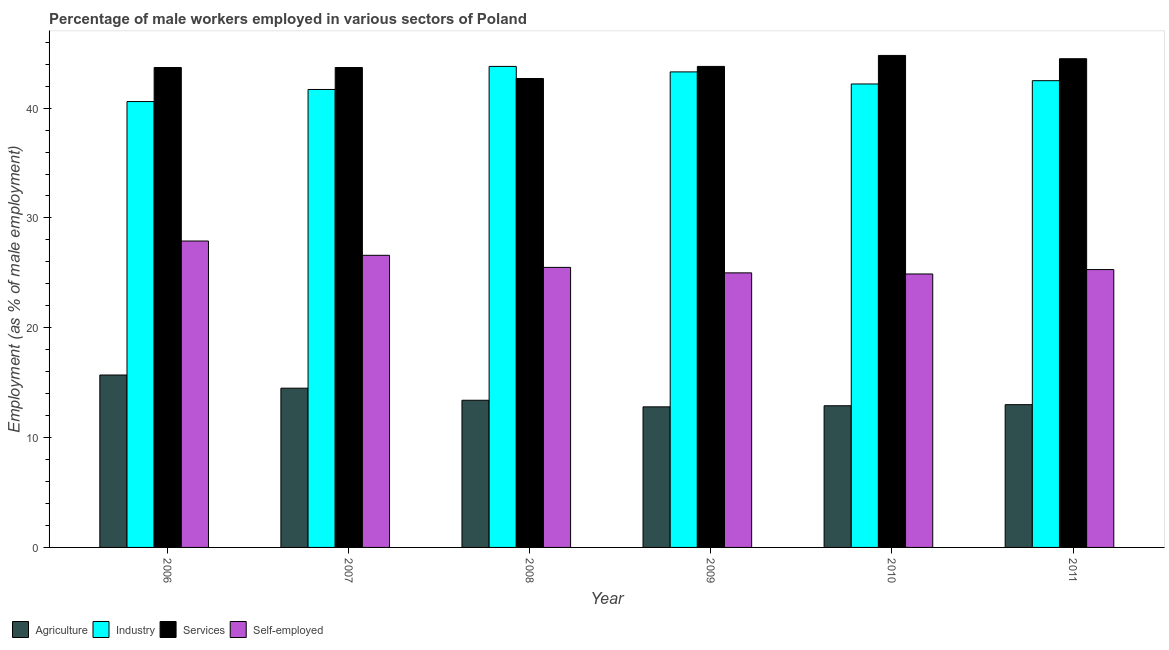How many different coloured bars are there?
Provide a succinct answer. 4. How many bars are there on the 3rd tick from the left?
Offer a terse response. 4. How many bars are there on the 6th tick from the right?
Make the answer very short. 4. What is the percentage of self employed male workers in 2006?
Your response must be concise. 27.9. Across all years, what is the maximum percentage of self employed male workers?
Provide a succinct answer. 27.9. Across all years, what is the minimum percentage of male workers in agriculture?
Your response must be concise. 12.8. What is the total percentage of male workers in agriculture in the graph?
Ensure brevity in your answer.  82.3. What is the difference between the percentage of male workers in agriculture in 2007 and that in 2010?
Keep it short and to the point. 1.6. What is the difference between the percentage of male workers in agriculture in 2010 and the percentage of male workers in services in 2007?
Provide a short and direct response. -1.6. What is the average percentage of male workers in services per year?
Provide a short and direct response. 43.87. In the year 2009, what is the difference between the percentage of male workers in agriculture and percentage of male workers in industry?
Provide a succinct answer. 0. What is the ratio of the percentage of male workers in agriculture in 2006 to that in 2011?
Your answer should be compact. 1.21. What is the difference between the highest and the second highest percentage of self employed male workers?
Your answer should be very brief. 1.3. What is the difference between the highest and the lowest percentage of self employed male workers?
Ensure brevity in your answer.  3. Is the sum of the percentage of male workers in industry in 2006 and 2011 greater than the maximum percentage of male workers in agriculture across all years?
Your response must be concise. Yes. What does the 3rd bar from the left in 2009 represents?
Provide a short and direct response. Services. What does the 4th bar from the right in 2007 represents?
Ensure brevity in your answer.  Agriculture. Are the values on the major ticks of Y-axis written in scientific E-notation?
Ensure brevity in your answer.  No. Does the graph contain any zero values?
Ensure brevity in your answer.  No. Does the graph contain grids?
Make the answer very short. No. How are the legend labels stacked?
Keep it short and to the point. Horizontal. What is the title of the graph?
Provide a short and direct response. Percentage of male workers employed in various sectors of Poland. What is the label or title of the Y-axis?
Offer a terse response. Employment (as % of male employment). What is the Employment (as % of male employment) in Agriculture in 2006?
Ensure brevity in your answer.  15.7. What is the Employment (as % of male employment) of Industry in 2006?
Your answer should be very brief. 40.6. What is the Employment (as % of male employment) in Services in 2006?
Provide a short and direct response. 43.7. What is the Employment (as % of male employment) in Self-employed in 2006?
Provide a short and direct response. 27.9. What is the Employment (as % of male employment) in Industry in 2007?
Offer a terse response. 41.7. What is the Employment (as % of male employment) of Services in 2007?
Provide a succinct answer. 43.7. What is the Employment (as % of male employment) of Self-employed in 2007?
Provide a succinct answer. 26.6. What is the Employment (as % of male employment) of Agriculture in 2008?
Provide a short and direct response. 13.4. What is the Employment (as % of male employment) of Industry in 2008?
Provide a short and direct response. 43.8. What is the Employment (as % of male employment) in Services in 2008?
Make the answer very short. 42.7. What is the Employment (as % of male employment) in Self-employed in 2008?
Make the answer very short. 25.5. What is the Employment (as % of male employment) in Agriculture in 2009?
Offer a very short reply. 12.8. What is the Employment (as % of male employment) of Industry in 2009?
Your answer should be very brief. 43.3. What is the Employment (as % of male employment) in Services in 2009?
Your response must be concise. 43.8. What is the Employment (as % of male employment) of Self-employed in 2009?
Your answer should be very brief. 25. What is the Employment (as % of male employment) in Agriculture in 2010?
Ensure brevity in your answer.  12.9. What is the Employment (as % of male employment) of Industry in 2010?
Ensure brevity in your answer.  42.2. What is the Employment (as % of male employment) of Services in 2010?
Provide a short and direct response. 44.8. What is the Employment (as % of male employment) of Self-employed in 2010?
Keep it short and to the point. 24.9. What is the Employment (as % of male employment) of Agriculture in 2011?
Give a very brief answer. 13. What is the Employment (as % of male employment) of Industry in 2011?
Give a very brief answer. 42.5. What is the Employment (as % of male employment) in Services in 2011?
Provide a succinct answer. 44.5. What is the Employment (as % of male employment) of Self-employed in 2011?
Ensure brevity in your answer.  25.3. Across all years, what is the maximum Employment (as % of male employment) in Agriculture?
Offer a very short reply. 15.7. Across all years, what is the maximum Employment (as % of male employment) of Industry?
Provide a succinct answer. 43.8. Across all years, what is the maximum Employment (as % of male employment) in Services?
Keep it short and to the point. 44.8. Across all years, what is the maximum Employment (as % of male employment) in Self-employed?
Offer a very short reply. 27.9. Across all years, what is the minimum Employment (as % of male employment) of Agriculture?
Give a very brief answer. 12.8. Across all years, what is the minimum Employment (as % of male employment) in Industry?
Your response must be concise. 40.6. Across all years, what is the minimum Employment (as % of male employment) in Services?
Make the answer very short. 42.7. Across all years, what is the minimum Employment (as % of male employment) of Self-employed?
Provide a succinct answer. 24.9. What is the total Employment (as % of male employment) of Agriculture in the graph?
Give a very brief answer. 82.3. What is the total Employment (as % of male employment) of Industry in the graph?
Ensure brevity in your answer.  254.1. What is the total Employment (as % of male employment) of Services in the graph?
Your answer should be very brief. 263.2. What is the total Employment (as % of male employment) of Self-employed in the graph?
Offer a very short reply. 155.2. What is the difference between the Employment (as % of male employment) of Industry in 2006 and that in 2007?
Offer a very short reply. -1.1. What is the difference between the Employment (as % of male employment) in Self-employed in 2006 and that in 2007?
Ensure brevity in your answer.  1.3. What is the difference between the Employment (as % of male employment) in Agriculture in 2006 and that in 2008?
Your answer should be very brief. 2.3. What is the difference between the Employment (as % of male employment) in Industry in 2006 and that in 2008?
Provide a short and direct response. -3.2. What is the difference between the Employment (as % of male employment) of Services in 2006 and that in 2008?
Provide a short and direct response. 1. What is the difference between the Employment (as % of male employment) of Self-employed in 2006 and that in 2008?
Provide a short and direct response. 2.4. What is the difference between the Employment (as % of male employment) in Services in 2006 and that in 2009?
Your answer should be compact. -0.1. What is the difference between the Employment (as % of male employment) of Self-employed in 2006 and that in 2009?
Ensure brevity in your answer.  2.9. What is the difference between the Employment (as % of male employment) of Industry in 2006 and that in 2010?
Give a very brief answer. -1.6. What is the difference between the Employment (as % of male employment) in Services in 2006 and that in 2010?
Provide a succinct answer. -1.1. What is the difference between the Employment (as % of male employment) of Services in 2006 and that in 2011?
Provide a succinct answer. -0.8. What is the difference between the Employment (as % of male employment) of Industry in 2007 and that in 2008?
Offer a terse response. -2.1. What is the difference between the Employment (as % of male employment) in Services in 2007 and that in 2008?
Offer a terse response. 1. What is the difference between the Employment (as % of male employment) in Industry in 2007 and that in 2009?
Give a very brief answer. -1.6. What is the difference between the Employment (as % of male employment) in Services in 2007 and that in 2009?
Offer a terse response. -0.1. What is the difference between the Employment (as % of male employment) of Self-employed in 2007 and that in 2010?
Ensure brevity in your answer.  1.7. What is the difference between the Employment (as % of male employment) of Agriculture in 2007 and that in 2011?
Your answer should be compact. 1.5. What is the difference between the Employment (as % of male employment) in Services in 2007 and that in 2011?
Give a very brief answer. -0.8. What is the difference between the Employment (as % of male employment) of Self-employed in 2007 and that in 2011?
Keep it short and to the point. 1.3. What is the difference between the Employment (as % of male employment) in Agriculture in 2008 and that in 2009?
Your response must be concise. 0.6. What is the difference between the Employment (as % of male employment) in Services in 2008 and that in 2009?
Provide a succinct answer. -1.1. What is the difference between the Employment (as % of male employment) of Self-employed in 2008 and that in 2009?
Provide a short and direct response. 0.5. What is the difference between the Employment (as % of male employment) in Agriculture in 2008 and that in 2010?
Offer a terse response. 0.5. What is the difference between the Employment (as % of male employment) of Services in 2008 and that in 2010?
Keep it short and to the point. -2.1. What is the difference between the Employment (as % of male employment) in Self-employed in 2008 and that in 2010?
Provide a succinct answer. 0.6. What is the difference between the Employment (as % of male employment) in Agriculture in 2008 and that in 2011?
Ensure brevity in your answer.  0.4. What is the difference between the Employment (as % of male employment) in Industry in 2008 and that in 2011?
Ensure brevity in your answer.  1.3. What is the difference between the Employment (as % of male employment) in Services in 2008 and that in 2011?
Provide a succinct answer. -1.8. What is the difference between the Employment (as % of male employment) in Self-employed in 2008 and that in 2011?
Your response must be concise. 0.2. What is the difference between the Employment (as % of male employment) in Agriculture in 2009 and that in 2010?
Provide a short and direct response. -0.1. What is the difference between the Employment (as % of male employment) in Services in 2009 and that in 2010?
Your response must be concise. -1. What is the difference between the Employment (as % of male employment) in Self-employed in 2009 and that in 2010?
Ensure brevity in your answer.  0.1. What is the difference between the Employment (as % of male employment) in Agriculture in 2009 and that in 2011?
Offer a terse response. -0.2. What is the difference between the Employment (as % of male employment) of Agriculture in 2010 and that in 2011?
Keep it short and to the point. -0.1. What is the difference between the Employment (as % of male employment) in Industry in 2010 and that in 2011?
Offer a very short reply. -0.3. What is the difference between the Employment (as % of male employment) in Services in 2010 and that in 2011?
Offer a very short reply. 0.3. What is the difference between the Employment (as % of male employment) in Agriculture in 2006 and the Employment (as % of male employment) in Services in 2007?
Your answer should be compact. -28. What is the difference between the Employment (as % of male employment) in Industry in 2006 and the Employment (as % of male employment) in Services in 2007?
Your response must be concise. -3.1. What is the difference between the Employment (as % of male employment) of Industry in 2006 and the Employment (as % of male employment) of Self-employed in 2007?
Offer a very short reply. 14. What is the difference between the Employment (as % of male employment) in Agriculture in 2006 and the Employment (as % of male employment) in Industry in 2008?
Your answer should be very brief. -28.1. What is the difference between the Employment (as % of male employment) in Agriculture in 2006 and the Employment (as % of male employment) in Industry in 2009?
Ensure brevity in your answer.  -27.6. What is the difference between the Employment (as % of male employment) in Agriculture in 2006 and the Employment (as % of male employment) in Services in 2009?
Provide a short and direct response. -28.1. What is the difference between the Employment (as % of male employment) in Agriculture in 2006 and the Employment (as % of male employment) in Self-employed in 2009?
Offer a terse response. -9.3. What is the difference between the Employment (as % of male employment) of Industry in 2006 and the Employment (as % of male employment) of Self-employed in 2009?
Give a very brief answer. 15.6. What is the difference between the Employment (as % of male employment) of Services in 2006 and the Employment (as % of male employment) of Self-employed in 2009?
Offer a very short reply. 18.7. What is the difference between the Employment (as % of male employment) in Agriculture in 2006 and the Employment (as % of male employment) in Industry in 2010?
Your answer should be compact. -26.5. What is the difference between the Employment (as % of male employment) of Agriculture in 2006 and the Employment (as % of male employment) of Services in 2010?
Your answer should be compact. -29.1. What is the difference between the Employment (as % of male employment) of Agriculture in 2006 and the Employment (as % of male employment) of Industry in 2011?
Your answer should be very brief. -26.8. What is the difference between the Employment (as % of male employment) in Agriculture in 2006 and the Employment (as % of male employment) in Services in 2011?
Offer a terse response. -28.8. What is the difference between the Employment (as % of male employment) in Agriculture in 2006 and the Employment (as % of male employment) in Self-employed in 2011?
Your response must be concise. -9.6. What is the difference between the Employment (as % of male employment) in Industry in 2006 and the Employment (as % of male employment) in Self-employed in 2011?
Provide a short and direct response. 15.3. What is the difference between the Employment (as % of male employment) in Services in 2006 and the Employment (as % of male employment) in Self-employed in 2011?
Your answer should be very brief. 18.4. What is the difference between the Employment (as % of male employment) in Agriculture in 2007 and the Employment (as % of male employment) in Industry in 2008?
Offer a terse response. -29.3. What is the difference between the Employment (as % of male employment) in Agriculture in 2007 and the Employment (as % of male employment) in Services in 2008?
Give a very brief answer. -28.2. What is the difference between the Employment (as % of male employment) of Services in 2007 and the Employment (as % of male employment) of Self-employed in 2008?
Make the answer very short. 18.2. What is the difference between the Employment (as % of male employment) of Agriculture in 2007 and the Employment (as % of male employment) of Industry in 2009?
Your answer should be compact. -28.8. What is the difference between the Employment (as % of male employment) of Agriculture in 2007 and the Employment (as % of male employment) of Services in 2009?
Keep it short and to the point. -29.3. What is the difference between the Employment (as % of male employment) in Industry in 2007 and the Employment (as % of male employment) in Services in 2009?
Offer a very short reply. -2.1. What is the difference between the Employment (as % of male employment) in Agriculture in 2007 and the Employment (as % of male employment) in Industry in 2010?
Ensure brevity in your answer.  -27.7. What is the difference between the Employment (as % of male employment) in Agriculture in 2007 and the Employment (as % of male employment) in Services in 2010?
Ensure brevity in your answer.  -30.3. What is the difference between the Employment (as % of male employment) of Agriculture in 2007 and the Employment (as % of male employment) of Self-employed in 2010?
Your response must be concise. -10.4. What is the difference between the Employment (as % of male employment) in Industry in 2007 and the Employment (as % of male employment) in Services in 2010?
Offer a terse response. -3.1. What is the difference between the Employment (as % of male employment) of Agriculture in 2007 and the Employment (as % of male employment) of Services in 2011?
Give a very brief answer. -30. What is the difference between the Employment (as % of male employment) in Industry in 2007 and the Employment (as % of male employment) in Self-employed in 2011?
Offer a terse response. 16.4. What is the difference between the Employment (as % of male employment) of Services in 2007 and the Employment (as % of male employment) of Self-employed in 2011?
Your response must be concise. 18.4. What is the difference between the Employment (as % of male employment) in Agriculture in 2008 and the Employment (as % of male employment) in Industry in 2009?
Make the answer very short. -29.9. What is the difference between the Employment (as % of male employment) of Agriculture in 2008 and the Employment (as % of male employment) of Services in 2009?
Your response must be concise. -30.4. What is the difference between the Employment (as % of male employment) in Agriculture in 2008 and the Employment (as % of male employment) in Self-employed in 2009?
Your response must be concise. -11.6. What is the difference between the Employment (as % of male employment) of Industry in 2008 and the Employment (as % of male employment) of Services in 2009?
Ensure brevity in your answer.  0. What is the difference between the Employment (as % of male employment) in Industry in 2008 and the Employment (as % of male employment) in Self-employed in 2009?
Your answer should be very brief. 18.8. What is the difference between the Employment (as % of male employment) in Agriculture in 2008 and the Employment (as % of male employment) in Industry in 2010?
Keep it short and to the point. -28.8. What is the difference between the Employment (as % of male employment) in Agriculture in 2008 and the Employment (as % of male employment) in Services in 2010?
Keep it short and to the point. -31.4. What is the difference between the Employment (as % of male employment) in Services in 2008 and the Employment (as % of male employment) in Self-employed in 2010?
Make the answer very short. 17.8. What is the difference between the Employment (as % of male employment) in Agriculture in 2008 and the Employment (as % of male employment) in Industry in 2011?
Ensure brevity in your answer.  -29.1. What is the difference between the Employment (as % of male employment) in Agriculture in 2008 and the Employment (as % of male employment) in Services in 2011?
Provide a succinct answer. -31.1. What is the difference between the Employment (as % of male employment) of Services in 2008 and the Employment (as % of male employment) of Self-employed in 2011?
Provide a succinct answer. 17.4. What is the difference between the Employment (as % of male employment) of Agriculture in 2009 and the Employment (as % of male employment) of Industry in 2010?
Offer a terse response. -29.4. What is the difference between the Employment (as % of male employment) in Agriculture in 2009 and the Employment (as % of male employment) in Services in 2010?
Offer a terse response. -32. What is the difference between the Employment (as % of male employment) in Agriculture in 2009 and the Employment (as % of male employment) in Self-employed in 2010?
Your answer should be very brief. -12.1. What is the difference between the Employment (as % of male employment) in Industry in 2009 and the Employment (as % of male employment) in Services in 2010?
Offer a terse response. -1.5. What is the difference between the Employment (as % of male employment) in Services in 2009 and the Employment (as % of male employment) in Self-employed in 2010?
Provide a short and direct response. 18.9. What is the difference between the Employment (as % of male employment) in Agriculture in 2009 and the Employment (as % of male employment) in Industry in 2011?
Your answer should be very brief. -29.7. What is the difference between the Employment (as % of male employment) in Agriculture in 2009 and the Employment (as % of male employment) in Services in 2011?
Your answer should be very brief. -31.7. What is the difference between the Employment (as % of male employment) of Industry in 2009 and the Employment (as % of male employment) of Services in 2011?
Your answer should be compact. -1.2. What is the difference between the Employment (as % of male employment) of Services in 2009 and the Employment (as % of male employment) of Self-employed in 2011?
Your answer should be compact. 18.5. What is the difference between the Employment (as % of male employment) in Agriculture in 2010 and the Employment (as % of male employment) in Industry in 2011?
Your answer should be very brief. -29.6. What is the difference between the Employment (as % of male employment) in Agriculture in 2010 and the Employment (as % of male employment) in Services in 2011?
Your answer should be compact. -31.6. What is the difference between the Employment (as % of male employment) in Industry in 2010 and the Employment (as % of male employment) in Self-employed in 2011?
Offer a very short reply. 16.9. What is the difference between the Employment (as % of male employment) of Services in 2010 and the Employment (as % of male employment) of Self-employed in 2011?
Your answer should be compact. 19.5. What is the average Employment (as % of male employment) in Agriculture per year?
Give a very brief answer. 13.72. What is the average Employment (as % of male employment) in Industry per year?
Make the answer very short. 42.35. What is the average Employment (as % of male employment) of Services per year?
Provide a succinct answer. 43.87. What is the average Employment (as % of male employment) of Self-employed per year?
Offer a terse response. 25.87. In the year 2006, what is the difference between the Employment (as % of male employment) of Agriculture and Employment (as % of male employment) of Industry?
Provide a succinct answer. -24.9. In the year 2006, what is the difference between the Employment (as % of male employment) in Agriculture and Employment (as % of male employment) in Services?
Ensure brevity in your answer.  -28. In the year 2006, what is the difference between the Employment (as % of male employment) of Agriculture and Employment (as % of male employment) of Self-employed?
Keep it short and to the point. -12.2. In the year 2006, what is the difference between the Employment (as % of male employment) in Industry and Employment (as % of male employment) in Services?
Offer a terse response. -3.1. In the year 2006, what is the difference between the Employment (as % of male employment) in Industry and Employment (as % of male employment) in Self-employed?
Keep it short and to the point. 12.7. In the year 2006, what is the difference between the Employment (as % of male employment) in Services and Employment (as % of male employment) in Self-employed?
Your answer should be compact. 15.8. In the year 2007, what is the difference between the Employment (as % of male employment) in Agriculture and Employment (as % of male employment) in Industry?
Provide a succinct answer. -27.2. In the year 2007, what is the difference between the Employment (as % of male employment) of Agriculture and Employment (as % of male employment) of Services?
Your answer should be very brief. -29.2. In the year 2007, what is the difference between the Employment (as % of male employment) in Agriculture and Employment (as % of male employment) in Self-employed?
Keep it short and to the point. -12.1. In the year 2007, what is the difference between the Employment (as % of male employment) in Industry and Employment (as % of male employment) in Self-employed?
Your response must be concise. 15.1. In the year 2007, what is the difference between the Employment (as % of male employment) of Services and Employment (as % of male employment) of Self-employed?
Make the answer very short. 17.1. In the year 2008, what is the difference between the Employment (as % of male employment) of Agriculture and Employment (as % of male employment) of Industry?
Provide a succinct answer. -30.4. In the year 2008, what is the difference between the Employment (as % of male employment) in Agriculture and Employment (as % of male employment) in Services?
Your answer should be very brief. -29.3. In the year 2008, what is the difference between the Employment (as % of male employment) of Industry and Employment (as % of male employment) of Services?
Your answer should be very brief. 1.1. In the year 2008, what is the difference between the Employment (as % of male employment) of Services and Employment (as % of male employment) of Self-employed?
Your answer should be compact. 17.2. In the year 2009, what is the difference between the Employment (as % of male employment) of Agriculture and Employment (as % of male employment) of Industry?
Provide a succinct answer. -30.5. In the year 2009, what is the difference between the Employment (as % of male employment) in Agriculture and Employment (as % of male employment) in Services?
Your answer should be compact. -31. In the year 2009, what is the difference between the Employment (as % of male employment) in Services and Employment (as % of male employment) in Self-employed?
Keep it short and to the point. 18.8. In the year 2010, what is the difference between the Employment (as % of male employment) in Agriculture and Employment (as % of male employment) in Industry?
Your answer should be very brief. -29.3. In the year 2010, what is the difference between the Employment (as % of male employment) in Agriculture and Employment (as % of male employment) in Services?
Ensure brevity in your answer.  -31.9. In the year 2010, what is the difference between the Employment (as % of male employment) of Industry and Employment (as % of male employment) of Services?
Your response must be concise. -2.6. In the year 2010, what is the difference between the Employment (as % of male employment) of Services and Employment (as % of male employment) of Self-employed?
Your answer should be compact. 19.9. In the year 2011, what is the difference between the Employment (as % of male employment) in Agriculture and Employment (as % of male employment) in Industry?
Your answer should be compact. -29.5. In the year 2011, what is the difference between the Employment (as % of male employment) of Agriculture and Employment (as % of male employment) of Services?
Your answer should be very brief. -31.5. In the year 2011, what is the difference between the Employment (as % of male employment) in Services and Employment (as % of male employment) in Self-employed?
Keep it short and to the point. 19.2. What is the ratio of the Employment (as % of male employment) in Agriculture in 2006 to that in 2007?
Keep it short and to the point. 1.08. What is the ratio of the Employment (as % of male employment) in Industry in 2006 to that in 2007?
Ensure brevity in your answer.  0.97. What is the ratio of the Employment (as % of male employment) in Self-employed in 2006 to that in 2007?
Keep it short and to the point. 1.05. What is the ratio of the Employment (as % of male employment) of Agriculture in 2006 to that in 2008?
Provide a short and direct response. 1.17. What is the ratio of the Employment (as % of male employment) of Industry in 2006 to that in 2008?
Your response must be concise. 0.93. What is the ratio of the Employment (as % of male employment) of Services in 2006 to that in 2008?
Provide a succinct answer. 1.02. What is the ratio of the Employment (as % of male employment) in Self-employed in 2006 to that in 2008?
Offer a terse response. 1.09. What is the ratio of the Employment (as % of male employment) in Agriculture in 2006 to that in 2009?
Keep it short and to the point. 1.23. What is the ratio of the Employment (as % of male employment) of Industry in 2006 to that in 2009?
Make the answer very short. 0.94. What is the ratio of the Employment (as % of male employment) in Self-employed in 2006 to that in 2009?
Your response must be concise. 1.12. What is the ratio of the Employment (as % of male employment) in Agriculture in 2006 to that in 2010?
Provide a succinct answer. 1.22. What is the ratio of the Employment (as % of male employment) in Industry in 2006 to that in 2010?
Your answer should be very brief. 0.96. What is the ratio of the Employment (as % of male employment) in Services in 2006 to that in 2010?
Your answer should be compact. 0.98. What is the ratio of the Employment (as % of male employment) in Self-employed in 2006 to that in 2010?
Make the answer very short. 1.12. What is the ratio of the Employment (as % of male employment) in Agriculture in 2006 to that in 2011?
Provide a short and direct response. 1.21. What is the ratio of the Employment (as % of male employment) of Industry in 2006 to that in 2011?
Ensure brevity in your answer.  0.96. What is the ratio of the Employment (as % of male employment) in Self-employed in 2006 to that in 2011?
Ensure brevity in your answer.  1.1. What is the ratio of the Employment (as % of male employment) of Agriculture in 2007 to that in 2008?
Your response must be concise. 1.08. What is the ratio of the Employment (as % of male employment) of Industry in 2007 to that in 2008?
Your answer should be very brief. 0.95. What is the ratio of the Employment (as % of male employment) of Services in 2007 to that in 2008?
Provide a succinct answer. 1.02. What is the ratio of the Employment (as % of male employment) in Self-employed in 2007 to that in 2008?
Give a very brief answer. 1.04. What is the ratio of the Employment (as % of male employment) in Agriculture in 2007 to that in 2009?
Provide a short and direct response. 1.13. What is the ratio of the Employment (as % of male employment) of Services in 2007 to that in 2009?
Offer a very short reply. 1. What is the ratio of the Employment (as % of male employment) in Self-employed in 2007 to that in 2009?
Keep it short and to the point. 1.06. What is the ratio of the Employment (as % of male employment) of Agriculture in 2007 to that in 2010?
Provide a short and direct response. 1.12. What is the ratio of the Employment (as % of male employment) of Services in 2007 to that in 2010?
Keep it short and to the point. 0.98. What is the ratio of the Employment (as % of male employment) of Self-employed in 2007 to that in 2010?
Your answer should be compact. 1.07. What is the ratio of the Employment (as % of male employment) of Agriculture in 2007 to that in 2011?
Offer a very short reply. 1.12. What is the ratio of the Employment (as % of male employment) in Industry in 2007 to that in 2011?
Provide a succinct answer. 0.98. What is the ratio of the Employment (as % of male employment) in Self-employed in 2007 to that in 2011?
Your answer should be very brief. 1.05. What is the ratio of the Employment (as % of male employment) in Agriculture in 2008 to that in 2009?
Your answer should be compact. 1.05. What is the ratio of the Employment (as % of male employment) in Industry in 2008 to that in 2009?
Make the answer very short. 1.01. What is the ratio of the Employment (as % of male employment) in Services in 2008 to that in 2009?
Provide a short and direct response. 0.97. What is the ratio of the Employment (as % of male employment) of Self-employed in 2008 to that in 2009?
Offer a very short reply. 1.02. What is the ratio of the Employment (as % of male employment) of Agriculture in 2008 to that in 2010?
Offer a very short reply. 1.04. What is the ratio of the Employment (as % of male employment) of Industry in 2008 to that in 2010?
Make the answer very short. 1.04. What is the ratio of the Employment (as % of male employment) in Services in 2008 to that in 2010?
Give a very brief answer. 0.95. What is the ratio of the Employment (as % of male employment) in Self-employed in 2008 to that in 2010?
Your answer should be very brief. 1.02. What is the ratio of the Employment (as % of male employment) of Agriculture in 2008 to that in 2011?
Ensure brevity in your answer.  1.03. What is the ratio of the Employment (as % of male employment) in Industry in 2008 to that in 2011?
Keep it short and to the point. 1.03. What is the ratio of the Employment (as % of male employment) of Services in 2008 to that in 2011?
Make the answer very short. 0.96. What is the ratio of the Employment (as % of male employment) in Self-employed in 2008 to that in 2011?
Make the answer very short. 1.01. What is the ratio of the Employment (as % of male employment) of Agriculture in 2009 to that in 2010?
Keep it short and to the point. 0.99. What is the ratio of the Employment (as % of male employment) of Industry in 2009 to that in 2010?
Offer a very short reply. 1.03. What is the ratio of the Employment (as % of male employment) in Services in 2009 to that in 2010?
Ensure brevity in your answer.  0.98. What is the ratio of the Employment (as % of male employment) in Self-employed in 2009 to that in 2010?
Your answer should be compact. 1. What is the ratio of the Employment (as % of male employment) of Agriculture in 2009 to that in 2011?
Keep it short and to the point. 0.98. What is the ratio of the Employment (as % of male employment) of Industry in 2009 to that in 2011?
Provide a short and direct response. 1.02. What is the ratio of the Employment (as % of male employment) of Services in 2009 to that in 2011?
Ensure brevity in your answer.  0.98. What is the ratio of the Employment (as % of male employment) of Self-employed in 2009 to that in 2011?
Give a very brief answer. 0.99. What is the ratio of the Employment (as % of male employment) in Industry in 2010 to that in 2011?
Keep it short and to the point. 0.99. What is the ratio of the Employment (as % of male employment) of Services in 2010 to that in 2011?
Your answer should be compact. 1.01. What is the ratio of the Employment (as % of male employment) in Self-employed in 2010 to that in 2011?
Give a very brief answer. 0.98. What is the difference between the highest and the second highest Employment (as % of male employment) in Agriculture?
Offer a terse response. 1.2. What is the difference between the highest and the lowest Employment (as % of male employment) of Agriculture?
Your answer should be very brief. 2.9. What is the difference between the highest and the lowest Employment (as % of male employment) of Industry?
Offer a very short reply. 3.2. What is the difference between the highest and the lowest Employment (as % of male employment) in Services?
Keep it short and to the point. 2.1. What is the difference between the highest and the lowest Employment (as % of male employment) in Self-employed?
Ensure brevity in your answer.  3. 